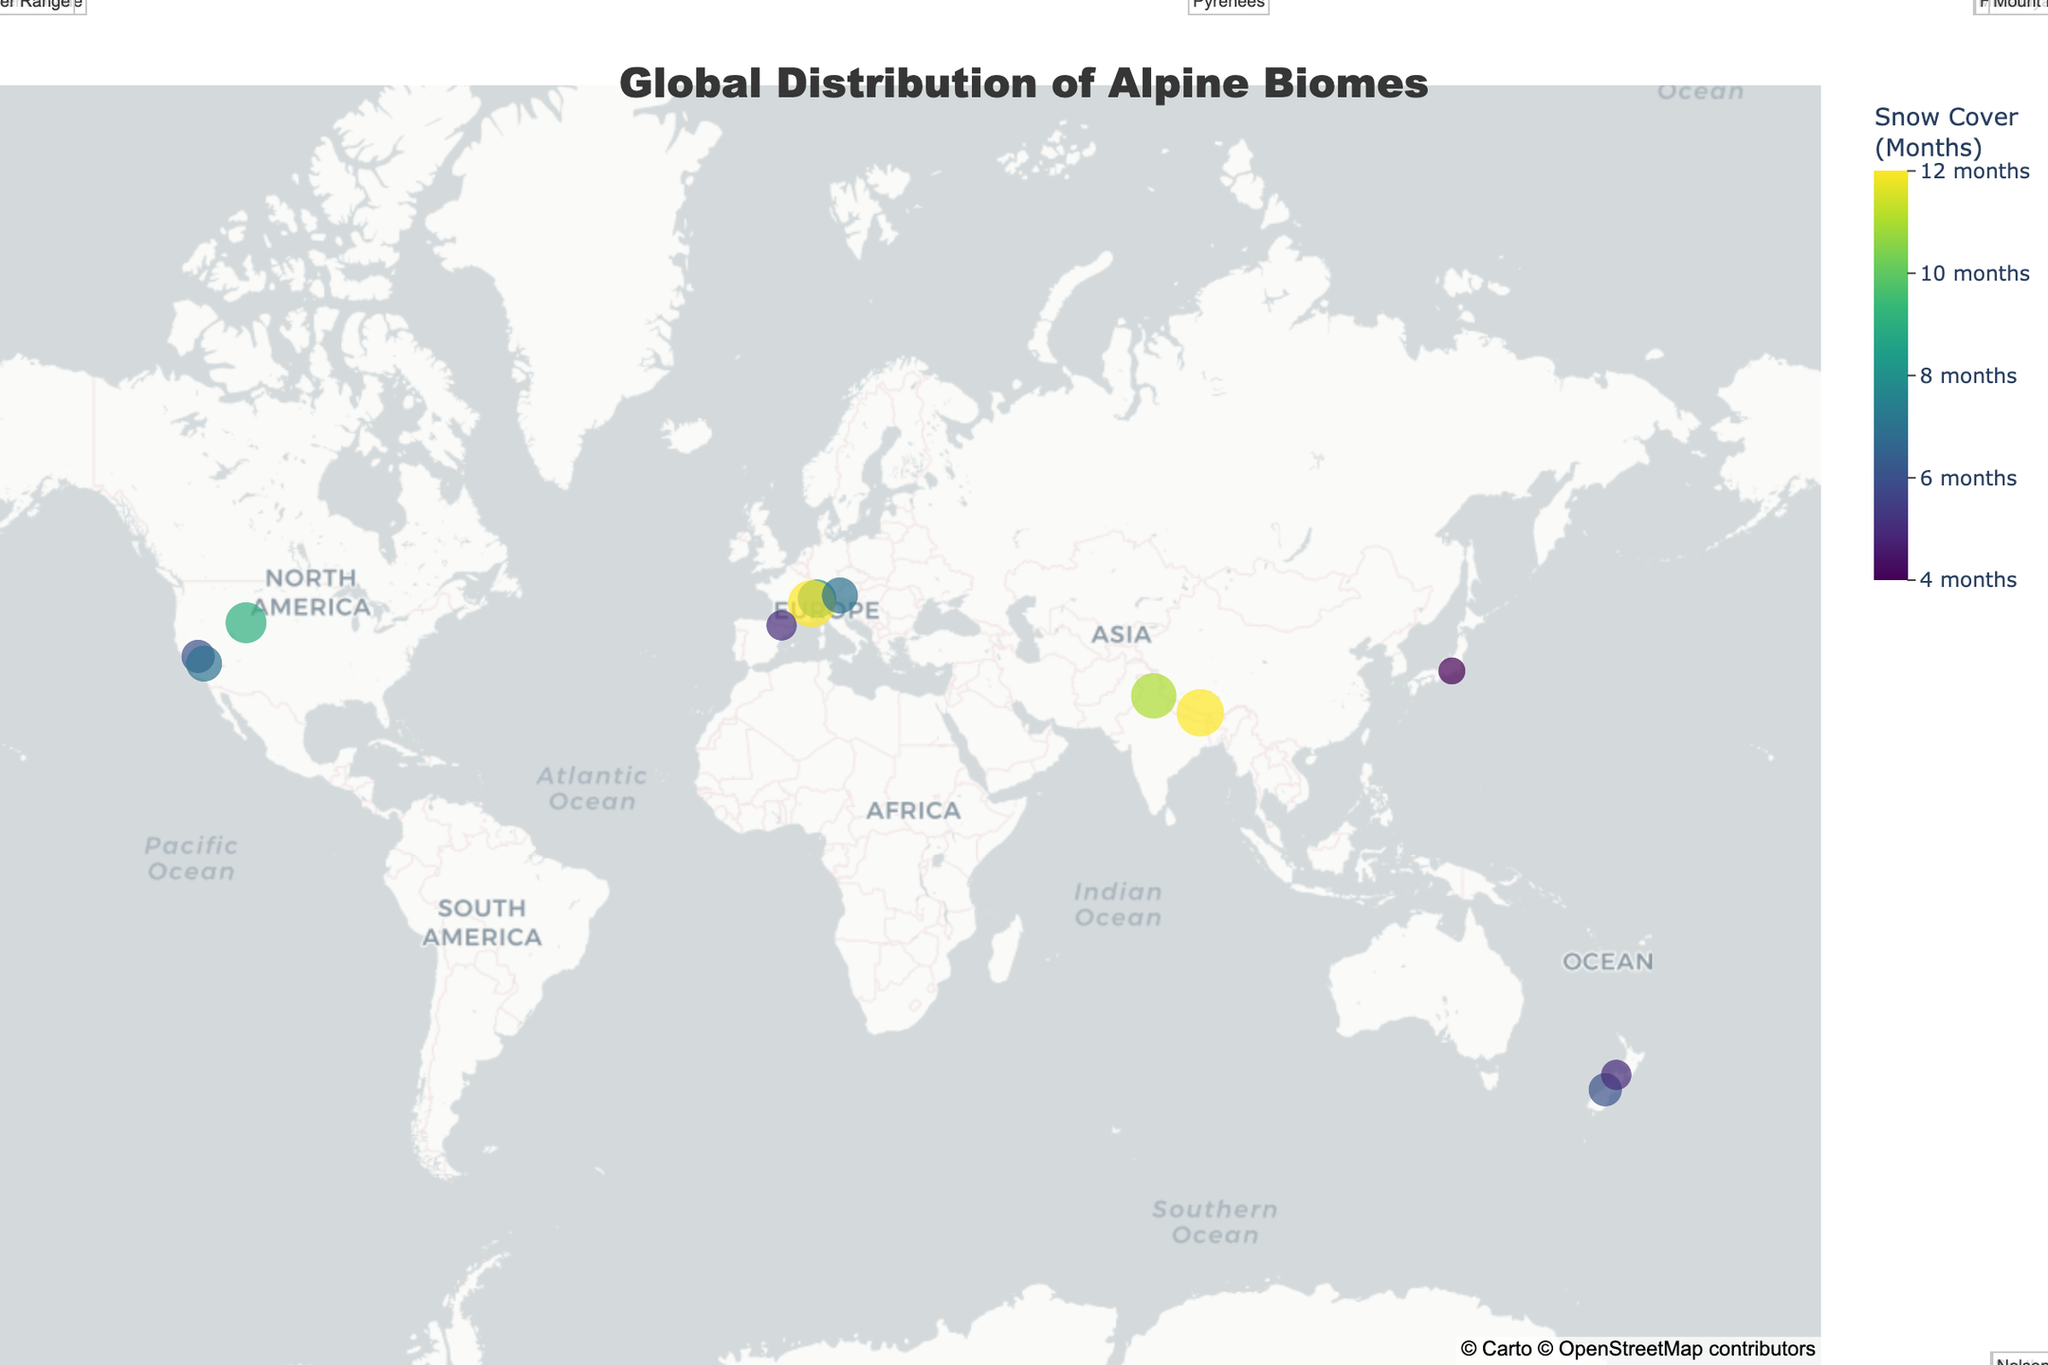Which mountain range has the highest elevation range? To find the highest elevation range, observe the "Elevation Range (m)" in the hover data. The highest range is found for Mount Everest with 5000-8800 meters.
Answer: Mount Everest How many mountain ranges are shown on the map? By counting the data points on the map (each representing a mountain range), you can see there are 12 different points.
Answer: 12 Which Alpine biome type has the longest snow cover? Look for the data points with the maximum 'Snow Cover Months' in the hover data. The 'Extreme Alpine' and 'Nival Zone' both have 12 months of snow cover.
Answer: Extreme Alpine, Nival Zone What is the average elevation range of the mountain ranges in the Northern Hemisphere? Sum up the minimum and maximum elevations of the mountain ranges in the Northern Hemisphere and divide by the number of those ranges (Swiss Alps, Mont Blanc Massif, Sierra Nevada, Great Western Divide, Wind River Range, Pyrenees, Hohe Tauern, Mount Fuji, Himalayan Range) as follows: (2000+4000 + 2500+4800 + 2900+4000 + 3000+4200 + 3100+4200 + 2300+3400 + 2500+3800 + 2400+3800 + 3500+5500) / 9 = (22200+33700) / 9 = 55900 / 9 = 6211.11 meters.
Answer: 6211.11 meters Which mountain range has the shortest period of snow cover? By observing the "Snow Cover Months" in the hover data, the lowest value is 4 months, which corresponds to Mount Fuji.
Answer: Mount Fuji Is there a positive relation between elevation and snow cover months? Compare the elevation ranges with the snow cover months by referring to the hover data. Although not perfectly consistent, higher elevations tend to have more months of snow cover, suggesting a general positive relationship.
Answer: Yes Which continents have the most diverse Alpine biome types? Look at the geographic distribution and types of Alpine biomes visible on the map. For the Northern Hemisphere, notable diversity is observed in North America and Europe.
Answer: North America, Europe What elevation range does the "Alpine Meadow" ecosystem belong to? Identify the data point labeled with "Alpine Meadow" in the hover data, which is found in the Great Western Divide with an elevation range of 3000-4200 meters.
Answer: 3000-4200 meters How many mountain ranges have snow cover for more than half the year? Determine the number of ranges with 'Snow Cover Months' greater than 6. These include Swiss Alps (8), Mont Blanc Massif (12), Great Western Divide (7), Wind River Range (9), Hohe Tauern (7), Himalayan Range (11), Mount Everest (12). There are 7 such mountain ranges.
Answer: 7 Which mountain range is the southernmost? Find the data point furthest south on the map, which is the Southern Alps located at latitude -43.5321.
Answer: Southern Alps 